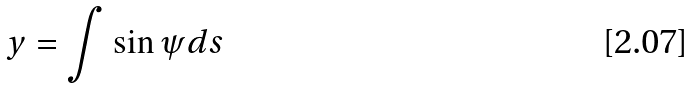Convert formula to latex. <formula><loc_0><loc_0><loc_500><loc_500>y = \int \sin \psi d s</formula> 